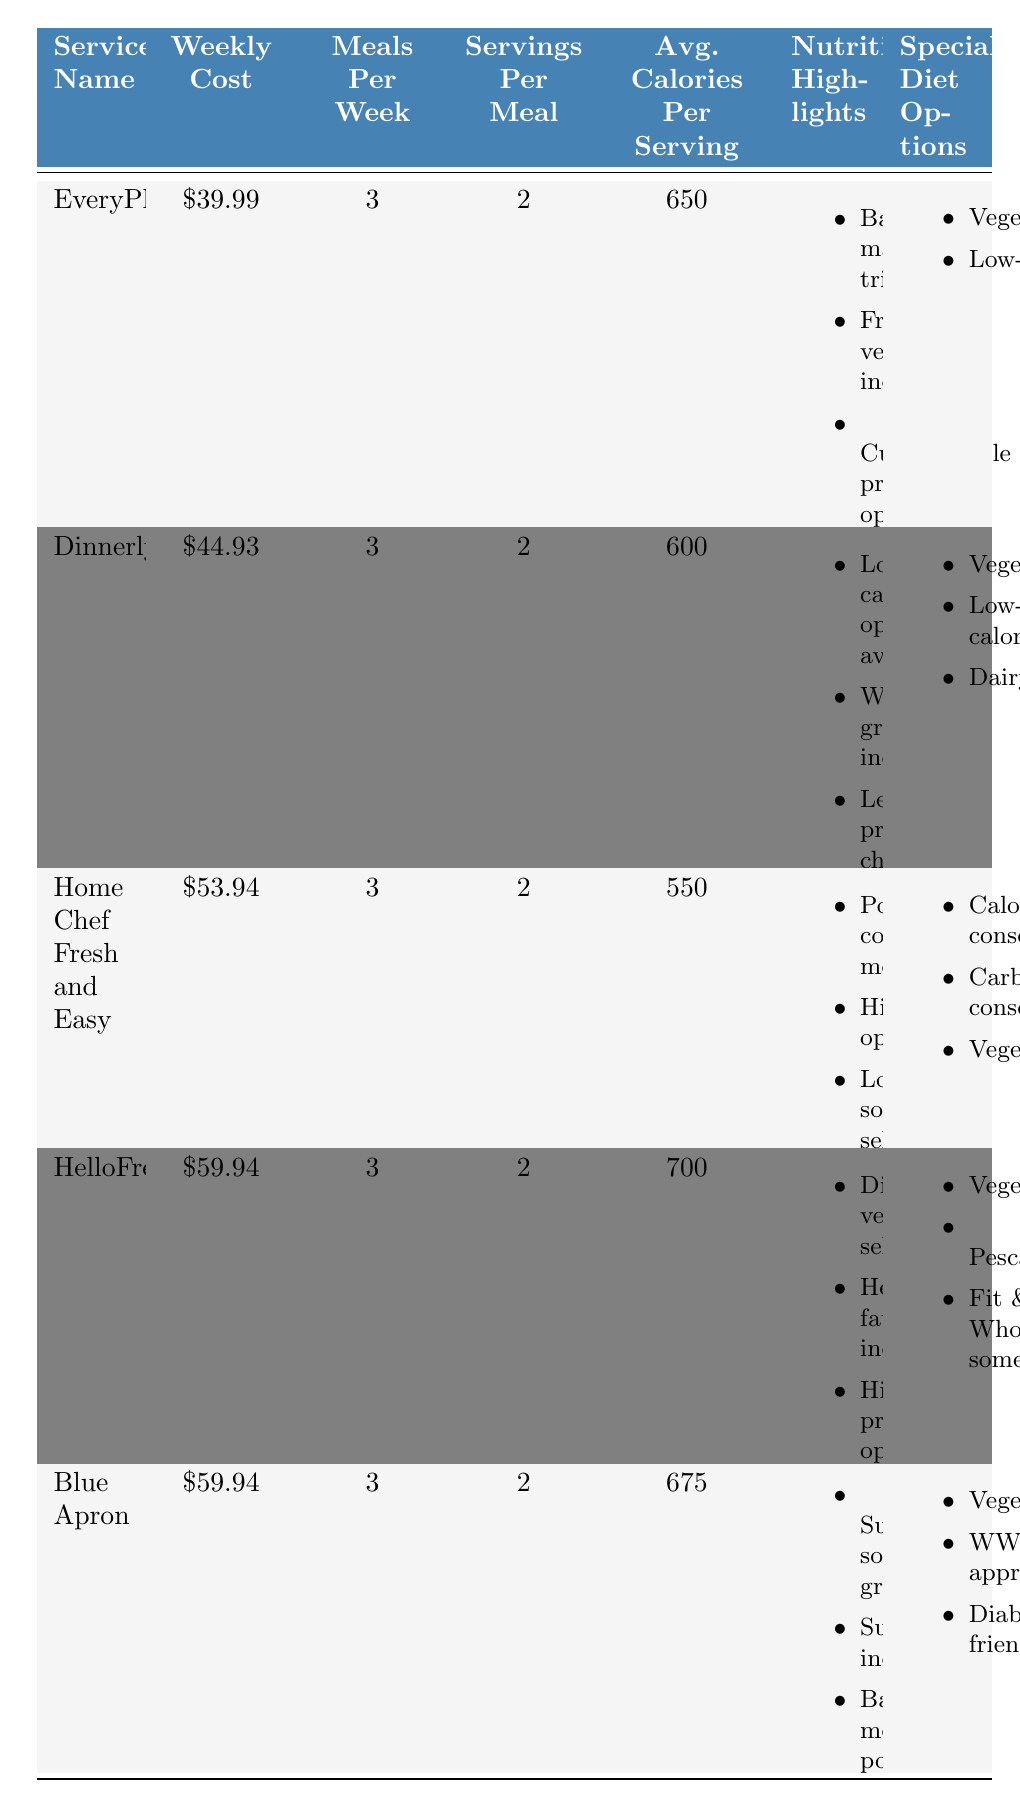What is the weekly cost of EveryPlate? The table lists the cost of EveryPlate as $39.99.
Answer: $39.99 How many meals per week do all the services provide? Each service provides 3 meals per week, as indicated in their respective columns in the table.
Answer: 3 meals Which meal prep service has the highest average calories per serving? By comparing the average calories per serving, HelloFresh has the highest at 700 calories.
Answer: HelloFresh Do any of the services offer a dairy-free option? Dinnerly offers a dairy-free option as listed under their special diet options in the table.
Answer: Yes Calculate the total weekly cost for the meal prep services with a caloric average above 650. HelloFresh has 700 calories, Blue Apron has 675 calories, and both have a weekly cost of $59.94. Summing these costs: $59.94 + $59.94 = $119.88.
Answer: $119.88 Is there any meal service that is both vegetarian and calorie-conscious? Home Chef Fresh and Easy provides vegetarian meals and also has options described as calorie-conscious in the special diet available.
Answer: Yes What is the average calories per serving for the services offering vegetarian options? The average calories can be calculated as follows: Average from EveryPlate (650) + Dinnerly (600) + Home Chef (550) + HelloFresh (700) + Blue Apron (675) = 3175; then divide by 5 services to find the average: 3175 / 5 = 635.
Answer: 635 Which service offers the most diverse special diet options? When assessing the special diet options, HelloFresh lists three (Vegetarian, Pescatarian, Fit & Wholesome), which is more than the other services.
Answer: HelloFresh What is the difference in weekly cost between Dinnerly and Home Chef Fresh and Easy? The weekly cost of Dinnerly is $44.93 and Home Chef is $53.94. Subtracting these gives $53.94 - $44.93 = $9.01.
Answer: $9.01 Are there any services that provide meals for those on a low-calorie diet? Both Dinnerly and Home Chef Fresh and Easy cater to low-calorie diets, as evidenced in their special diet options.
Answer: Yes 